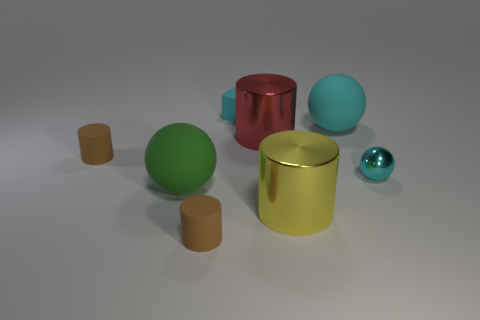What number of other things are there of the same color as the small metal object?
Your response must be concise. 2. What color is the matte cylinder behind the big metallic cylinder that is in front of the big rubber object in front of the large cyan rubber object?
Give a very brief answer. Brown. The other rubber object that is the same shape as the green thing is what size?
Make the answer very short. Large. Is the number of brown rubber objects to the left of the cyan cube less than the number of cyan things to the right of the big cyan rubber object?
Offer a very short reply. No. There is a big thing that is to the left of the large yellow shiny cylinder and behind the large green thing; what is its shape?
Ensure brevity in your answer.  Cylinder. What is the size of the other cylinder that is the same material as the yellow cylinder?
Keep it short and to the point. Large. Does the rubber cube have the same color as the large object behind the big red object?
Provide a short and direct response. Yes. What is the material of the big thing that is to the right of the red object and in front of the tiny cyan sphere?
Offer a very short reply. Metal. What is the size of the other ball that is the same color as the small sphere?
Your response must be concise. Large. There is a brown matte thing in front of the yellow object; is its shape the same as the yellow object in front of the tiny cube?
Provide a short and direct response. Yes. 